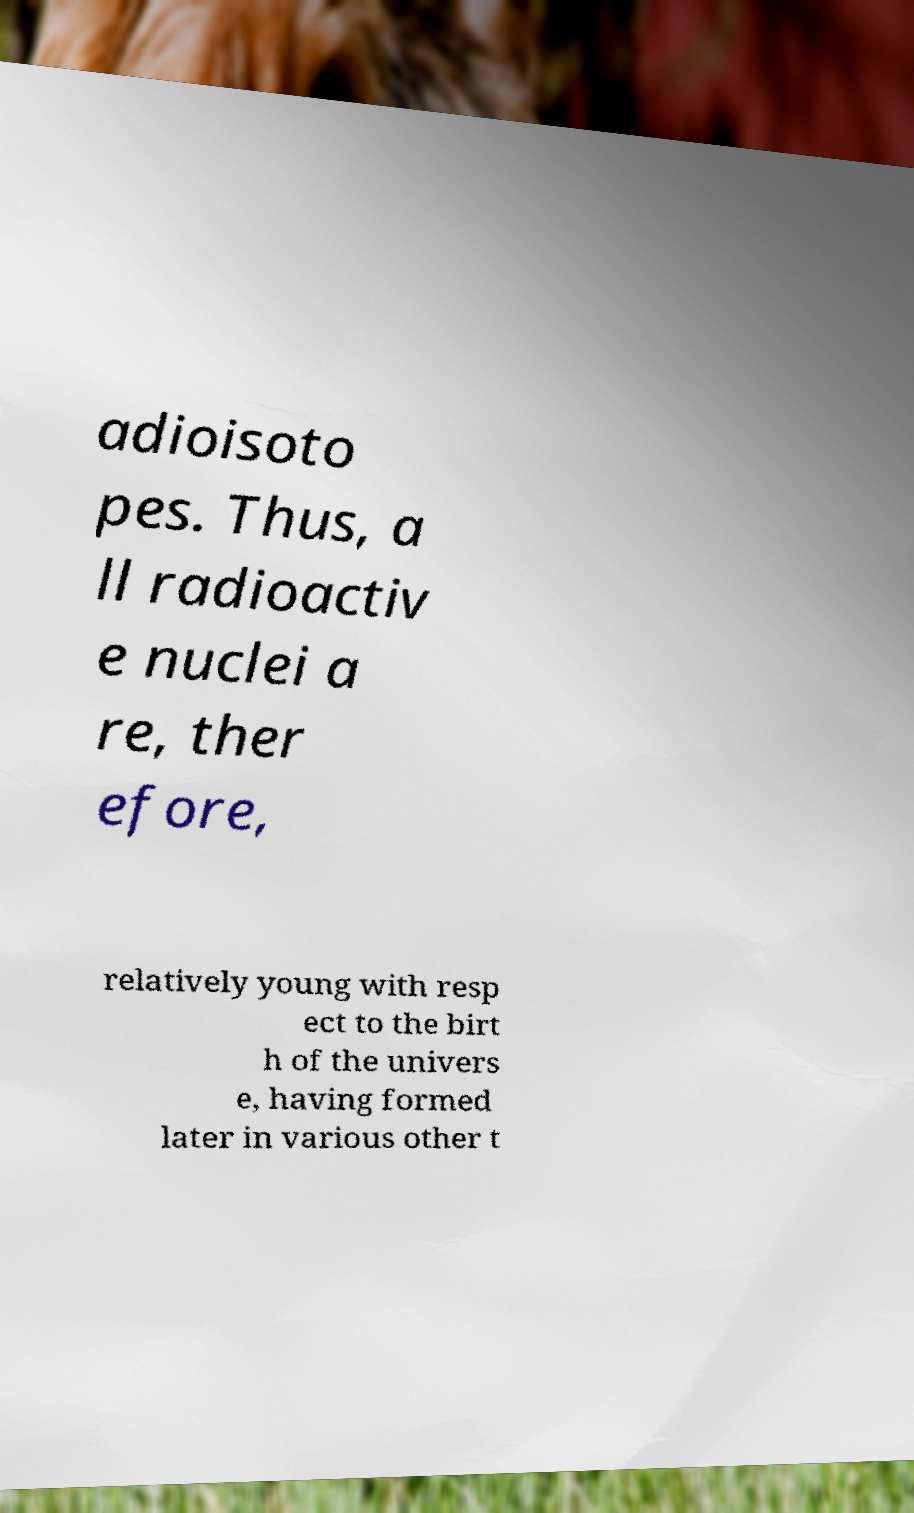For documentation purposes, I need the text within this image transcribed. Could you provide that? adioisoto pes. Thus, a ll radioactiv e nuclei a re, ther efore, relatively young with resp ect to the birt h of the univers e, having formed later in various other t 